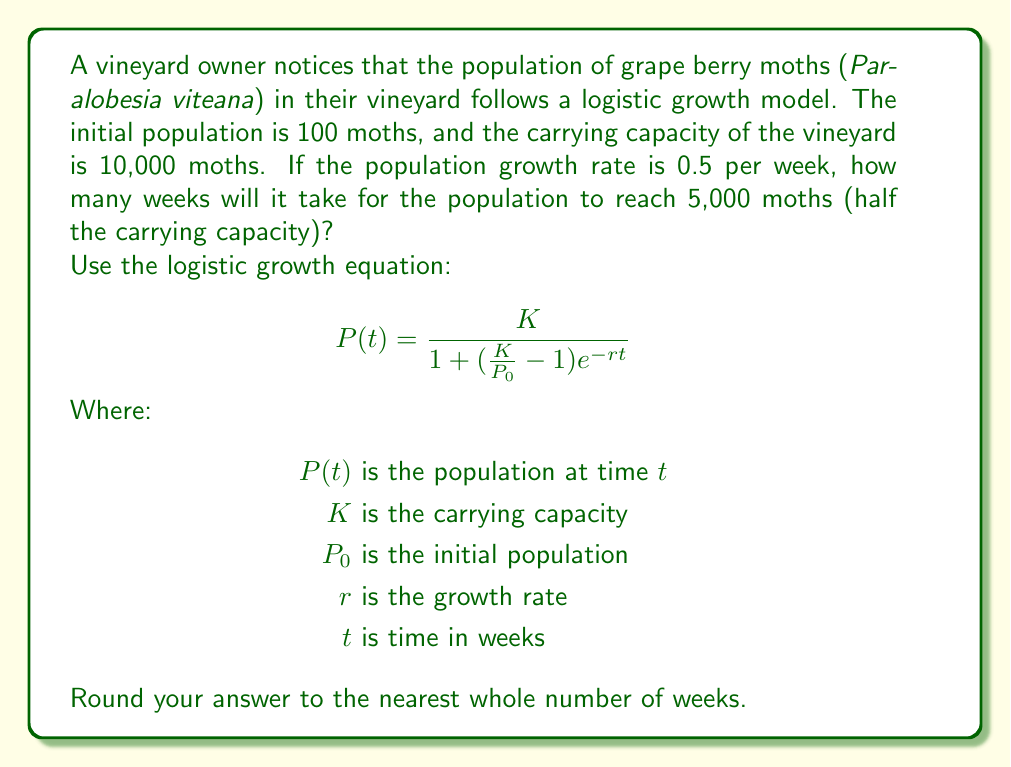Solve this math problem. Let's approach this step-by-step:

1) We are given:
   $K = 10,000$ (carrying capacity)
   $P_0 = 100$ (initial population)
   $r = 0.5$ (growth rate per week)
   $P(t) = 5,000$ (target population, half of carrying capacity)

2) We need to solve for $t$ in the logistic growth equation:

   $$5000 = \frac{10000}{1 + (\frac{10000}{100} - 1)e^{-0.5t}}$$

3) Let's simplify the right side of the equation:

   $$5000 = \frac{10000}{1 + 99e^{-0.5t}}$$

4) Now, let's solve for $t$:
   
   $$\frac{5000}{10000} = \frac{1}{1 + 99e^{-0.5t}}$$
   
   $$0.5 = \frac{1}{1 + 99e^{-0.5t}}$$
   
   $$2 = 1 + 99e^{-0.5t}$$
   
   $$1 = 99e^{-0.5t}$$
   
   $$\frac{1}{99} = e^{-0.5t}$$

5) Taking the natural log of both sides:

   $$\ln(\frac{1}{99}) = -0.5t$$
   
   $$-4.59512 = -0.5t$$

6) Solving for $t$:

   $$t = \frac{4.59512}{0.5} = 9.19024$$

7) Rounding to the nearest whole number:

   $$t \approx 9\text{ weeks}$$
Answer: 9 weeks 